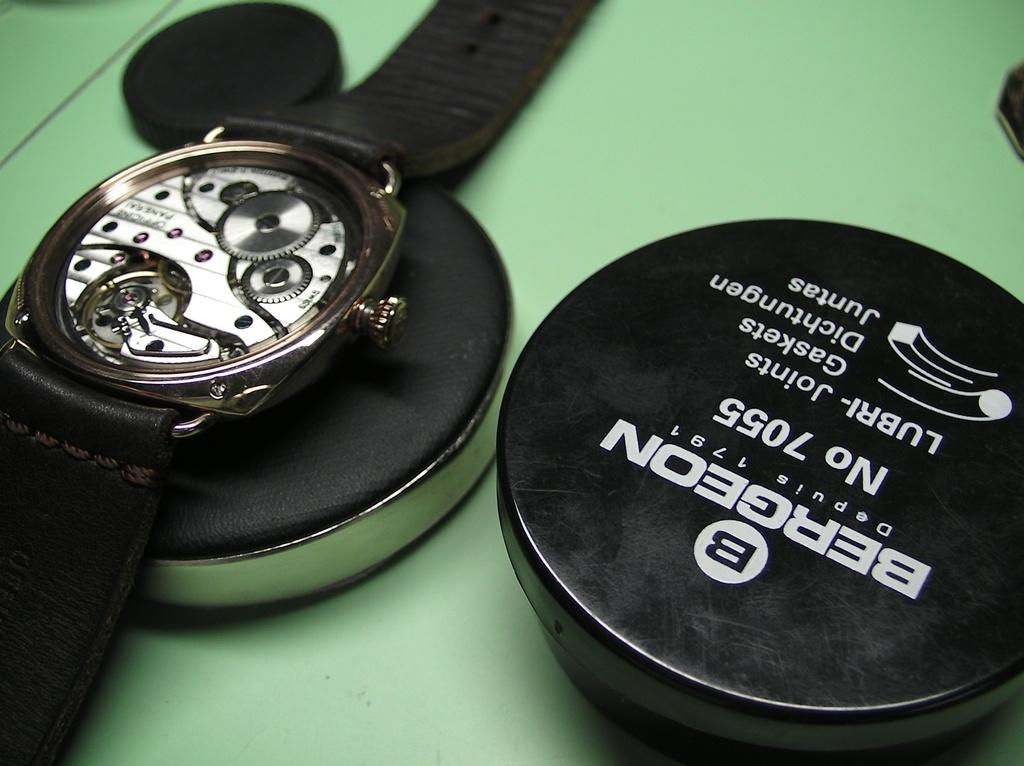Provide a one-sentence caption for the provided image. Bergeon is being used to lubricate a watch without a face. 